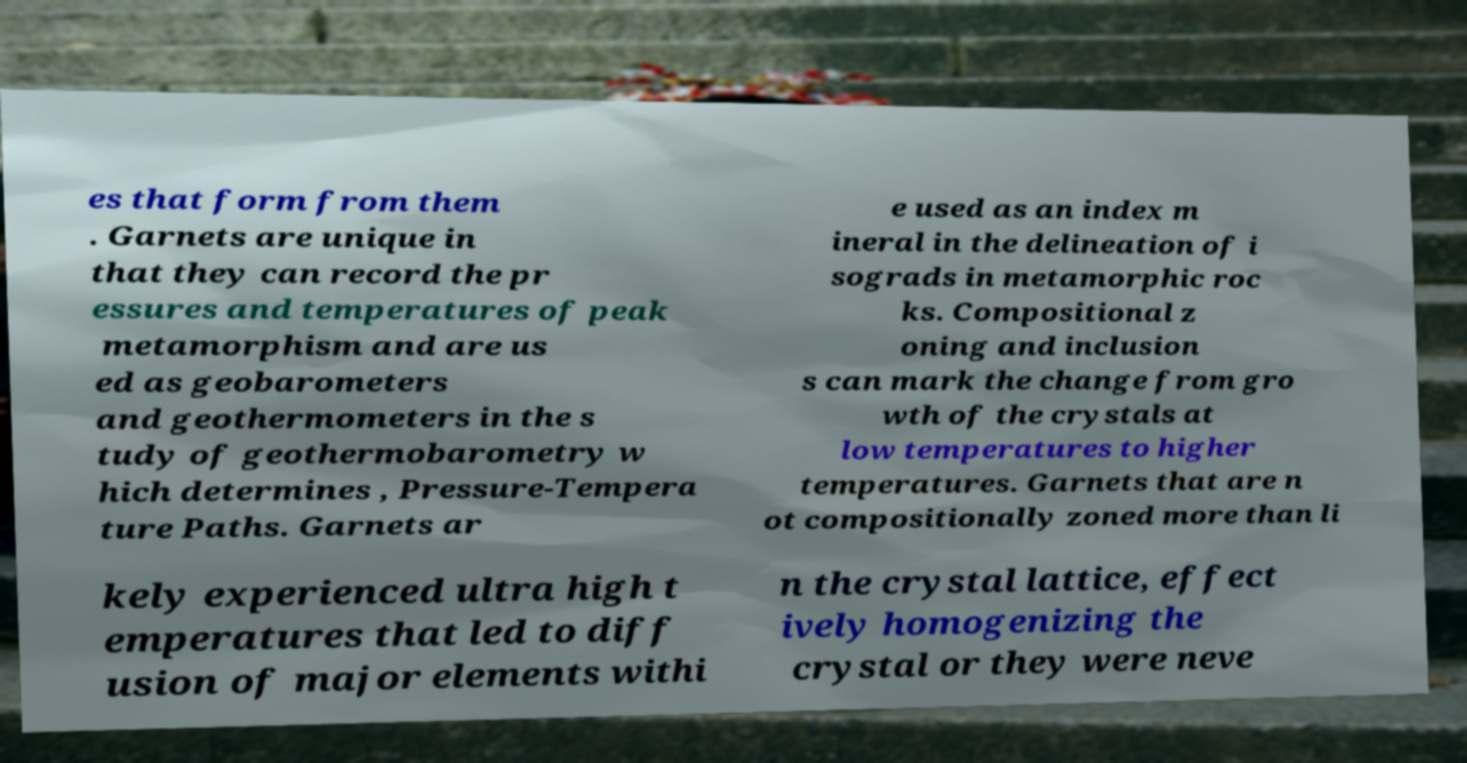What messages or text are displayed in this image? I need them in a readable, typed format. es that form from them . Garnets are unique in that they can record the pr essures and temperatures of peak metamorphism and are us ed as geobarometers and geothermometers in the s tudy of geothermobarometry w hich determines , Pressure-Tempera ture Paths. Garnets ar e used as an index m ineral in the delineation of i sograds in metamorphic roc ks. Compositional z oning and inclusion s can mark the change from gro wth of the crystals at low temperatures to higher temperatures. Garnets that are n ot compositionally zoned more than li kely experienced ultra high t emperatures that led to diff usion of major elements withi n the crystal lattice, effect ively homogenizing the crystal or they were neve 